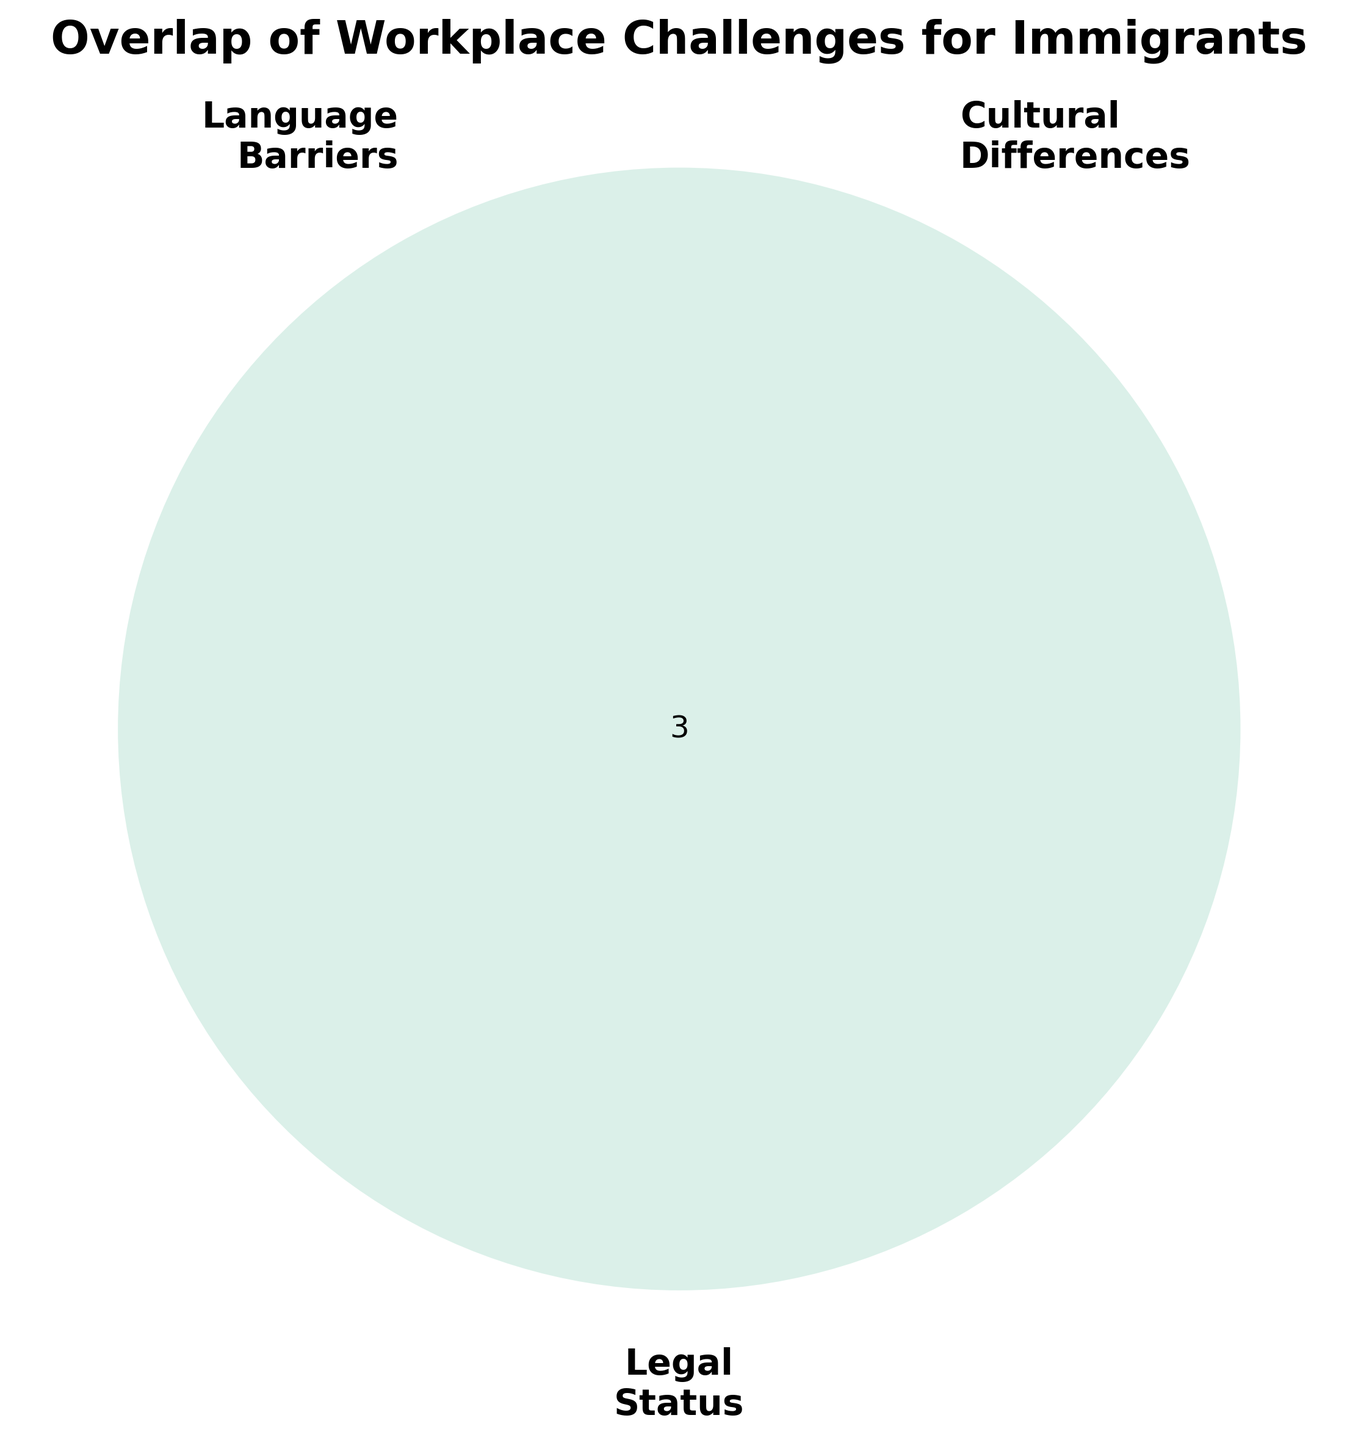What is the title of the Venn diagram? The title is usually displayed at the top of the figure, in larger and bold font to distinguish it from other text elements. In this case, the title is "Overlap of Workplace Challenges for Immigrants".
Answer: Overlap of Workplace Challenges for Immigrants What are the three main categories shown in the Venn diagram? The main categories are labeled outside each of the three circles. These labels are 'Language Barriers', 'Cultural Differences', and 'Legal Status'.
Answer: Language Barriers, Cultural Differences, Legal Status What color is used for the 'Language Barriers' category? The Venn diagram uses distinct colors to differentiate between categories. By looking at the diagram, 'Language Barriers' is shown in a color similar to light red or pink.
Answer: Light red/pink Which section of the Venn diagram represents the intersection of all three categories? The intersection of all three categories is where all three circles overlap. This central part captures challenges impacting immigrants with language barriers, cultural differences, and legal status issues simultaneously.
Answer: The central overlapping section How many unique sub-sections are formed by the intersections of the three categories? Counting all unique sections formed by the overlap of the three circles provides the total number of segments in the Venn diagram. There are 7 sections: (Language Barriers only, Cultural Differences only, Legal Status only, Language Barriers and Cultural Differences, Language Barriers and Legal Status, Cultural Differences and Legal Status, and all three categories intersecting).
Answer: 7 Which two categories are associated with 'Communication Issues'? By identifying where 'Communication Issues' falls in the overlapping circles, it appears in the section where 'Language Barriers' and 'Cultural Differences' intersect.
Answer: Language Barriers, Cultural Differences What is the relationship between 'Legal Status' and 'Discrimination'? To find this, observe where 'Discrimination' is located. It's in the section where 'Cultural Differences' and 'Legal Status' overlap, indicating that this is a challenge linked to both categories.
Answer: Cultural Differences and Legal Status Are 'Visa Concerns' related to both 'Language Barriers' and 'Cultural Differences'? Observing the Venn diagram for 'Visa Concerns', it is located in the section where 'Language Barriers' and 'Legal Status' intersect, but not in the part intersecting with 'Cultural Differences'.
Answer: No What common challenges do 'Language Barriers' and 'Legal Status' share? By examining the intersection of 'Language Barriers' and 'Legal Status', we see they share common challenges such as 'Visa Concerns'.
Answer: Visa Concerns 